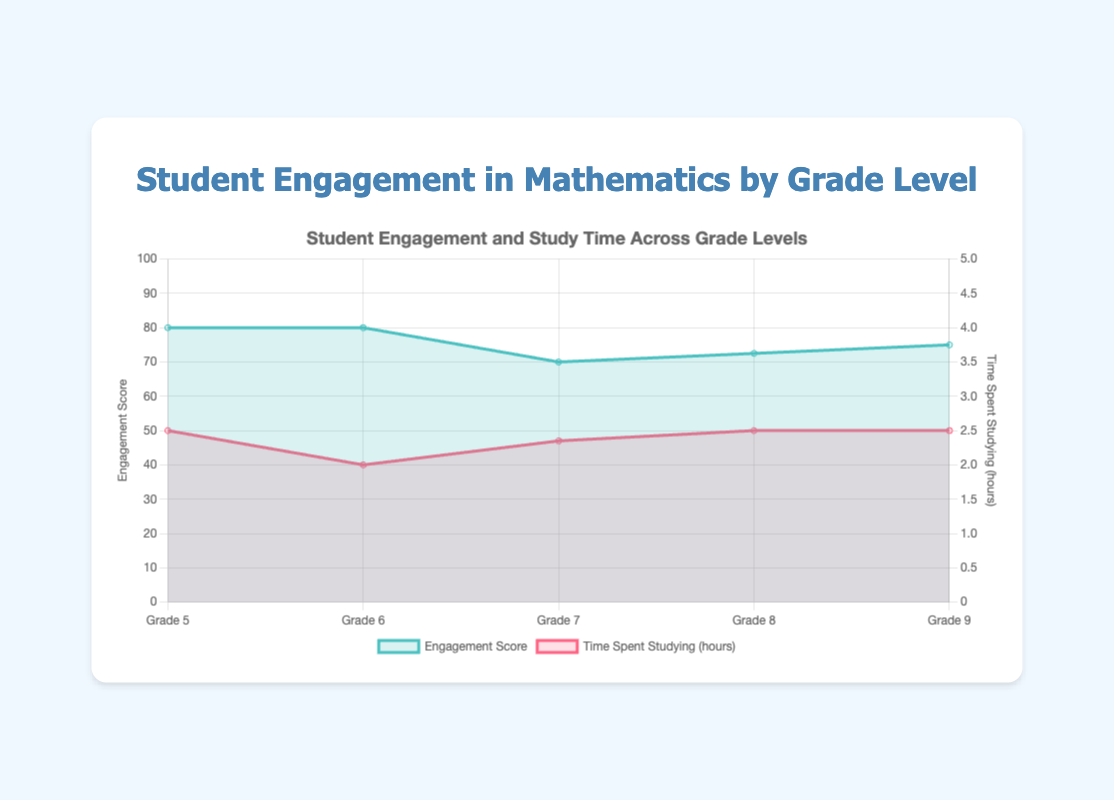What is the title of the chart? The title of the chart can be found at the top and it summarizes the main subject of the figure.
Answer: Student Engagement and Study Time Across Grade Levels What are the variables displayed on the left and right y-axes? The y-axes labels provide this information: the left y-axis represents Engagement Score and the right y-axis represents Time Spent Studying (hours).
Answer: Engagement Score and Time Spent Studying (hours) How many grade levels are represented in the chart? By counting the unique labels on the x-axis, we can determine the number of grade levels.
Answer: 5 Which grade level has the highest average engagement score? To find this, observe the peaks of the Engagement Score line across different grade levels.
Answer: Grade 8 Which grade level has the lowest average engagement score? Identify the lowest point on the Engagement Score line for the grade levels.
Answer: Grade 8 How does the average time spent studying (in hours) change from Grade 5 to Grade 9? Track the points on the Time Spent Studying line from Grade 5 to Grade 9 and describe the trend.
Answer: It generally increases Compare the average engagement score and time spent studying hours for Grade 7. Look at the specific points for Grade 7 on both lines and compare their values.
Answer: Engagement Score: 70, Time Spent Studying: 2.35 hours In which grade level do students spend the most time studying on average? Locate the highest point on the Time Spent Studying line to find the grade level.
Answer: Grade 8 Calculate the average engagement score across all grade levels. Sum all the average engagement scores for each grade level and divide by the number of grade levels: (80 + 80 + 70 + 72.5 + 75) / 5 = 75
Answer: 75 What insights can you draw about the relationship between time spent studying and engagement score? By examining both lines, one can see that they generally increase together, suggesting students who spend more time studying tend to have higher engagement scores.
Answer: Positive correlation 